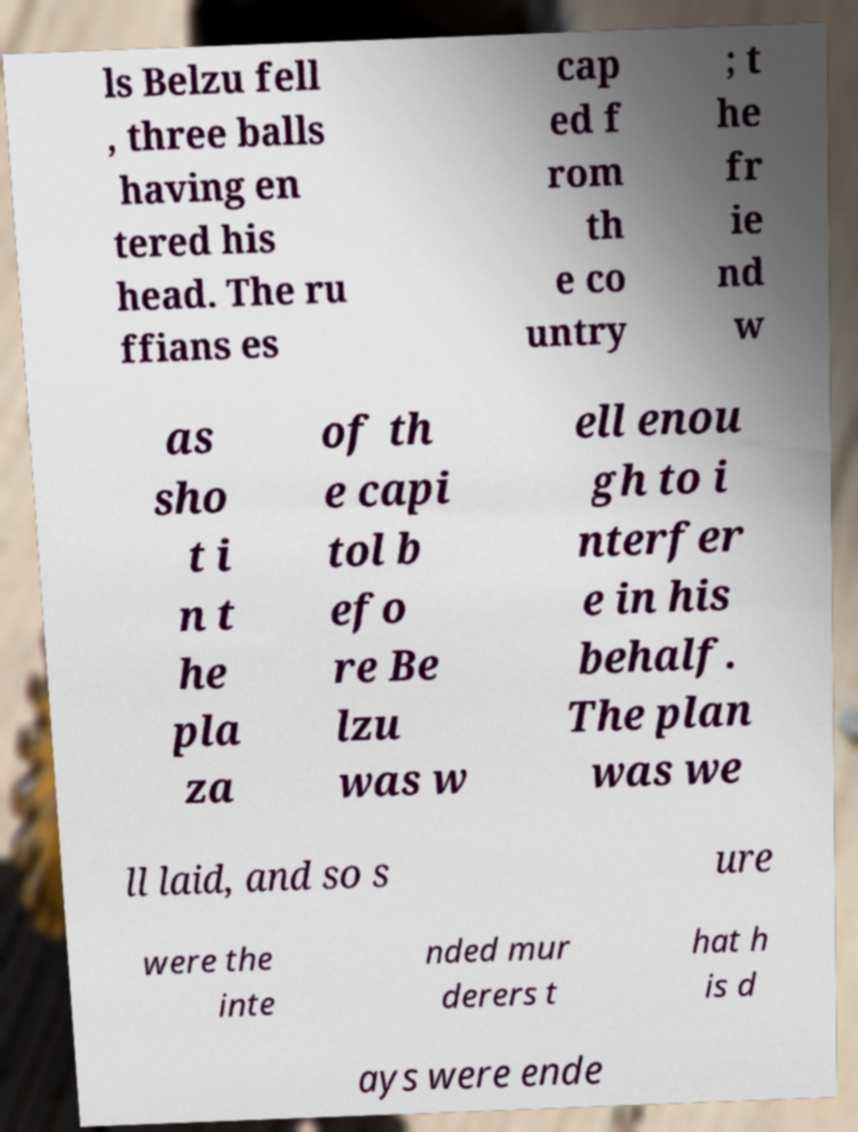Could you assist in decoding the text presented in this image and type it out clearly? ls Belzu fell , three balls having en tered his head. The ru ffians es cap ed f rom th e co untry ; t he fr ie nd w as sho t i n t he pla za of th e capi tol b efo re Be lzu was w ell enou gh to i nterfer e in his behalf. The plan was we ll laid, and so s ure were the inte nded mur derers t hat h is d ays were ende 